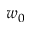<formula> <loc_0><loc_0><loc_500><loc_500>w _ { 0 }</formula> 